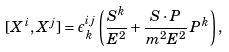Convert formula to latex. <formula><loc_0><loc_0><loc_500><loc_500>[ X ^ { i } , X ^ { j } ] = \epsilon ^ { i j } _ { \, k } \left ( \frac { S ^ { k } } { E ^ { 2 } } + \frac { S \cdot P } { m ^ { 2 } E ^ { 2 } } \, P ^ { k } \right ) ,</formula> 